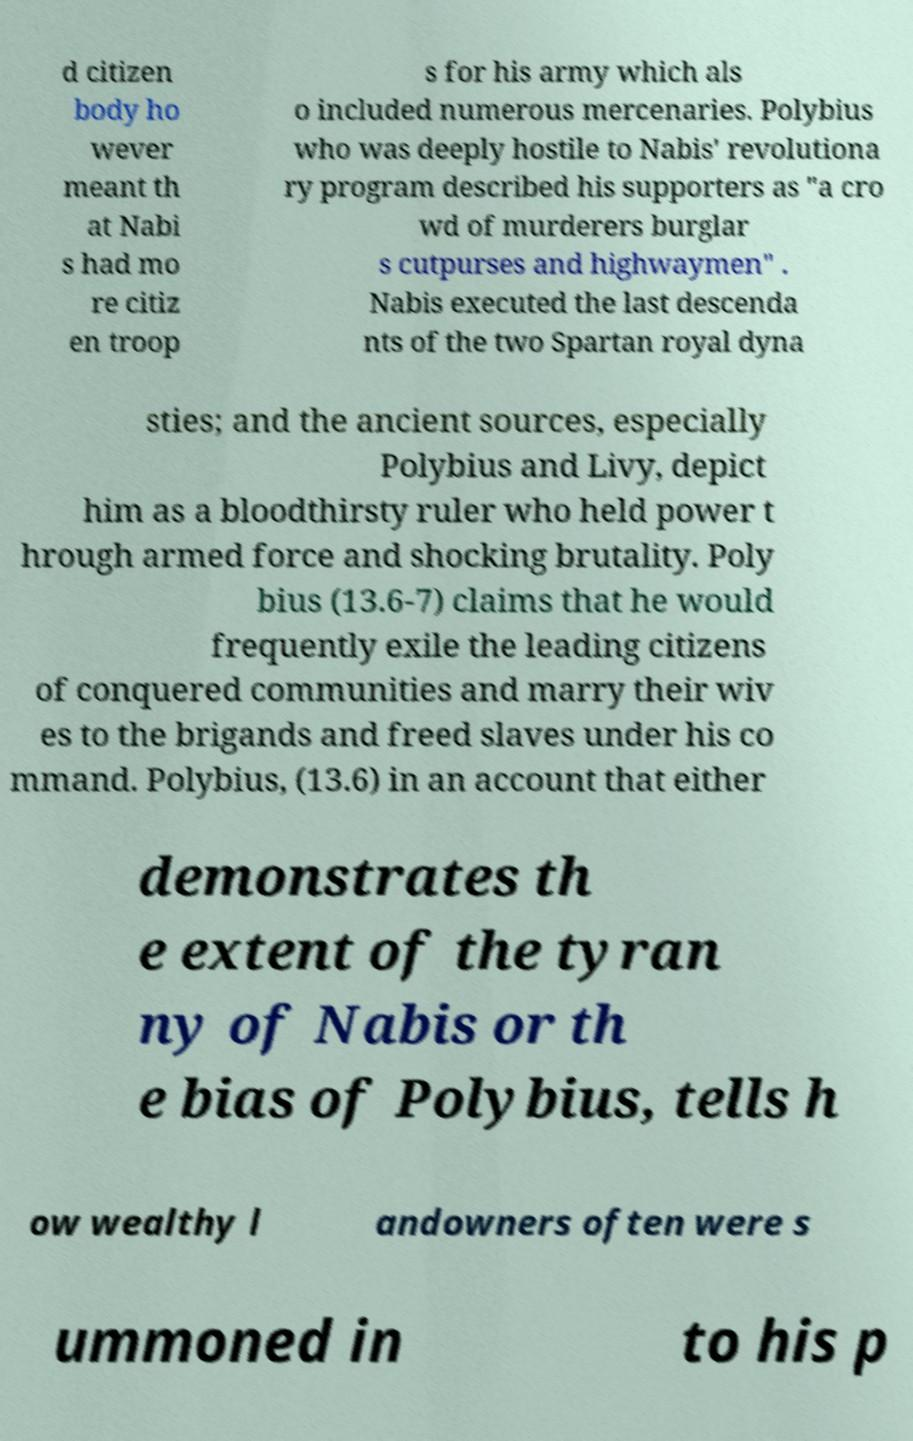Please identify and transcribe the text found in this image. d citizen body ho wever meant th at Nabi s had mo re citiz en troop s for his army which als o included numerous mercenaries. Polybius who was deeply hostile to Nabis' revolutiona ry program described his supporters as "a cro wd of murderers burglar s cutpurses and highwaymen" . Nabis executed the last descenda nts of the two Spartan royal dyna sties; and the ancient sources, especially Polybius and Livy, depict him as a bloodthirsty ruler who held power t hrough armed force and shocking brutality. Poly bius (13.6-7) claims that he would frequently exile the leading citizens of conquered communities and marry their wiv es to the brigands and freed slaves under his co mmand. Polybius, (13.6) in an account that either demonstrates th e extent of the tyran ny of Nabis or th e bias of Polybius, tells h ow wealthy l andowners often were s ummoned in to his p 